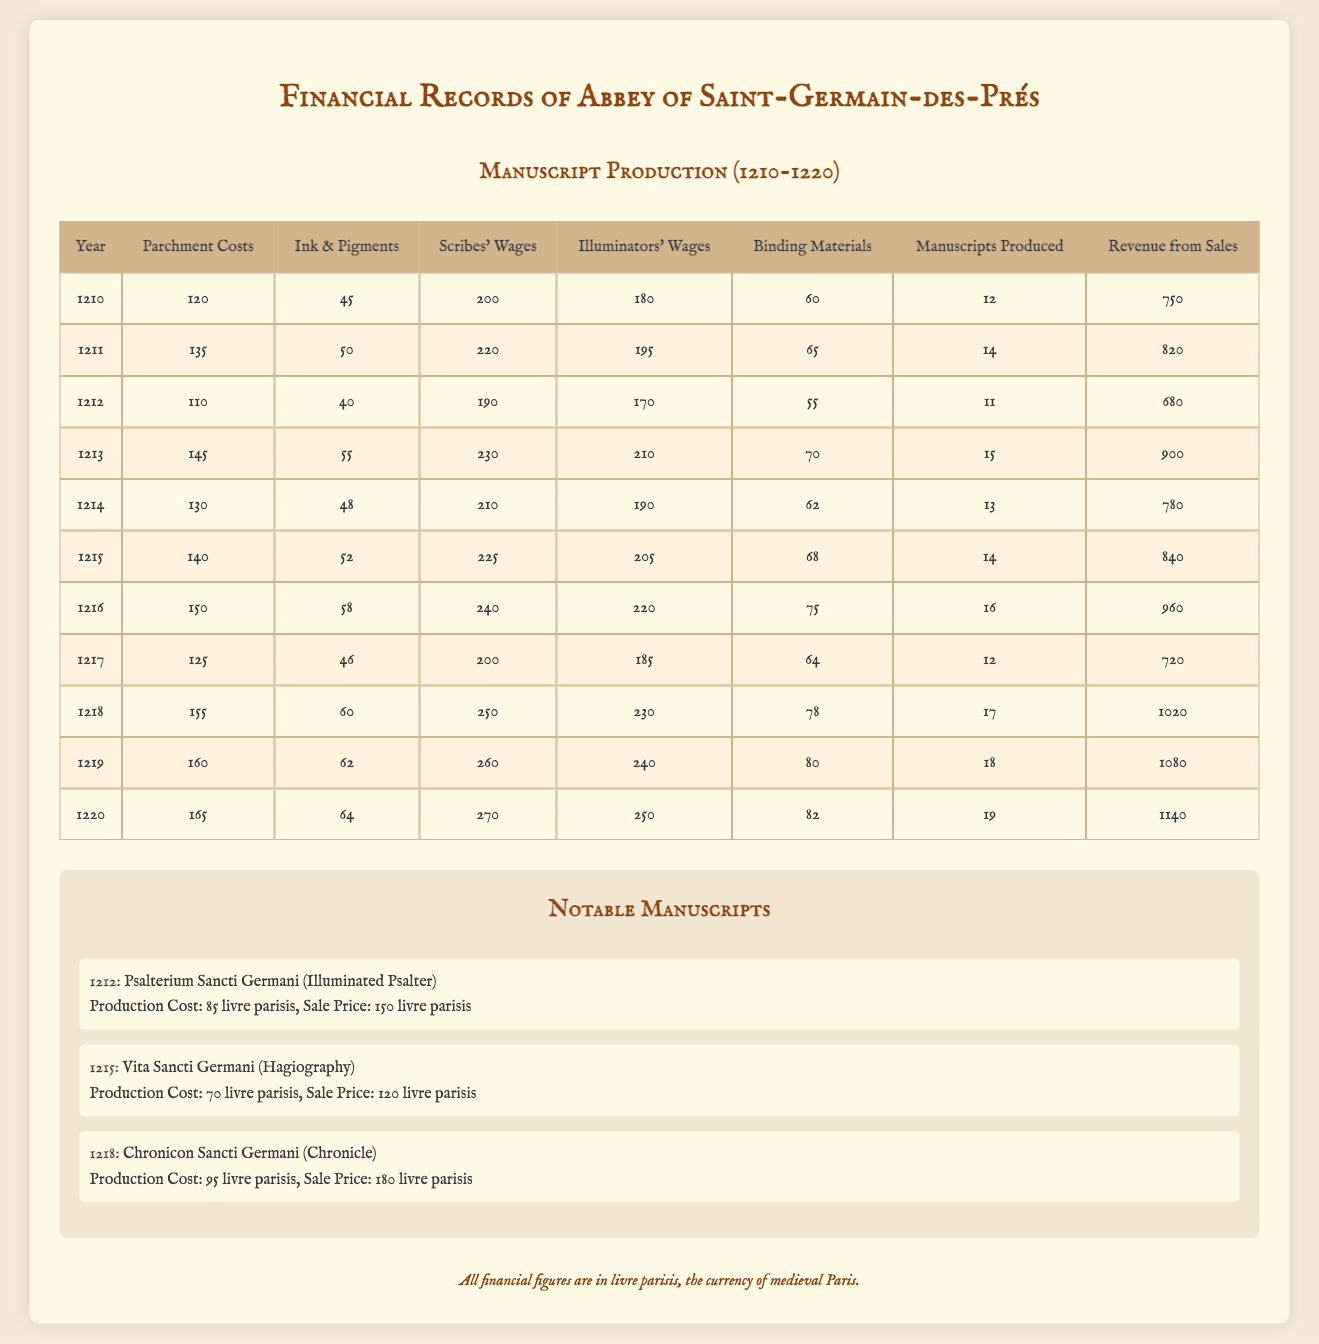What was the total revenue from manuscript sales in 1213? The revenue from sales for the year 1213 is specified directly in the table. Looking at the row for the year 1213, the total revenue from sales is 900.
Answer: 900 What was the average cost of parchment over the decade? The parchment costs for the years are: 120, 135, 110, 145, 130, 140, 150, 125, 155, 160, and 165. Adding these gives a total of 1510 (120 + 135 + 110 + 145 + 130 + 140 + 150 + 125 + 155 + 160 + 165 = 1510). There are 11 years, so the average is 1510/11 = 137.27, which can be rounded to 137.
Answer: 137 In which year was the highest revenue recorded? To find the highest revenue, we can review the revenue figures for each year. The revenues from sales for the years are: 750, 820, 680, 900, 780, 840, 960, 720, 1020, 1080, and 1140. The maximum value is 1140 in the year 1220.
Answer: 1220 Did the total manuscripts produced increase every year from 1210 to 1220? By examining the manuscript production figures for each year: 12, 14, 11, 15, 13, 14, 16, 12, 17, 18, and 19, we can see that there are fluctuations, specifically a decrease from 14 to 11 in 1212 and then a decrease again from 16 to 12 in 1217. Therefore, the production did not consistently increase each year.
Answer: No What is the difference in total wages paid to scribes between the highest and lowest years? The scribes’ wages for the years are: 200, 220, 190, 230, 210, 225, 240, 200, 250, 260, and 270. The highest wage is 270 in 1220 and the lowest is 190 in 1212. The difference is 270 - 190 = 80.
Answer: 80 What percentage of total manuscript production was achieved in 1218 compared to the entire decade? The total manuscripts produced from 1210 to 1220 are the sum of: 12, 14, 11, 15, 13, 14, 16, 12, 17, 18, and 19, which equals  151. The total produced in 1218 was 17. Calculating the percentage: (17/151) * 100 = 11.29%.
Answer: 11.29% Was the production cost for "Chronicon Sancti Germani" higher than its sale price? The production cost for "Chronicon Sancti Germani" in 1218 is 95 livre parisis and its sale price is 180 livre parisis. Since 95 is less than 180, the production cost was not higher than the sale price.
Answer: No Which year had the highest total cost in materials and wages combined? To calculate the total cost for each year, we add all costs: parchment costs, ink and pigments, scribes' wages, illuminators' wages, and binding materials. The highest total cost was in 1219 with: 160 + 62 + 260 + 240 + 80 = 802.
Answer: 1219 